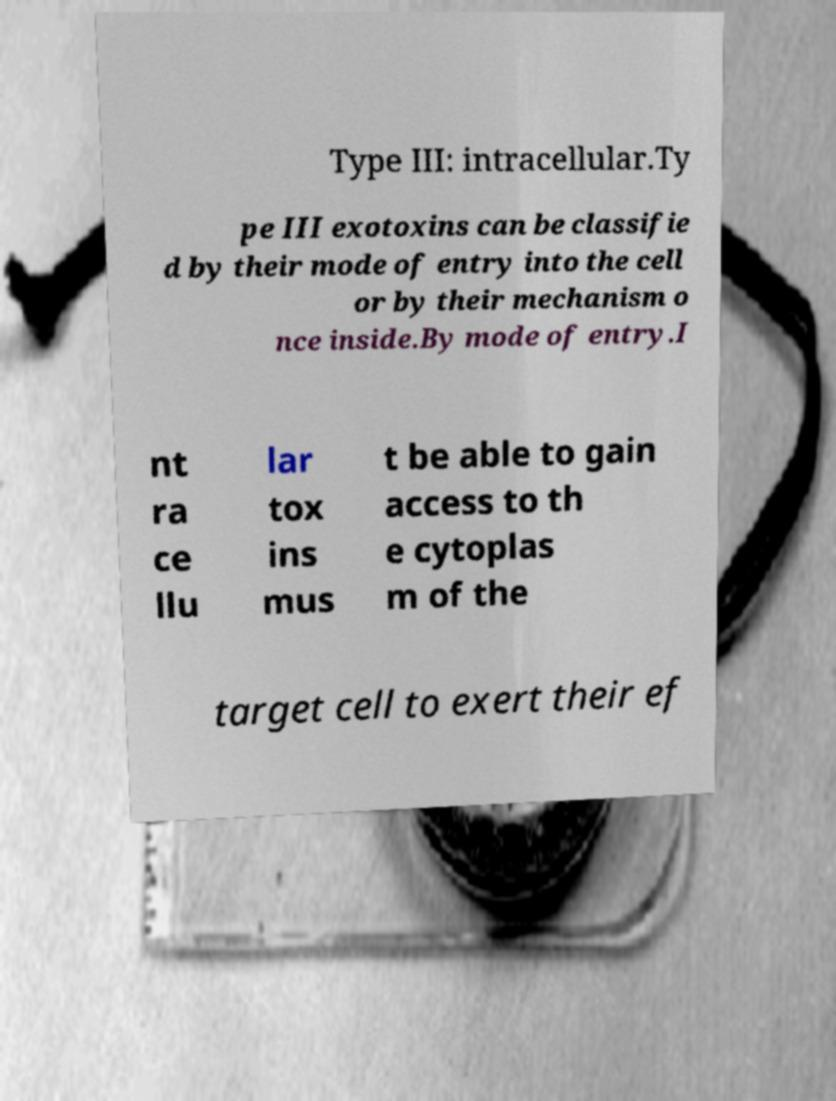Could you assist in decoding the text presented in this image and type it out clearly? Type III: intracellular.Ty pe III exotoxins can be classifie d by their mode of entry into the cell or by their mechanism o nce inside.By mode of entry.I nt ra ce llu lar tox ins mus t be able to gain access to th e cytoplas m of the target cell to exert their ef 